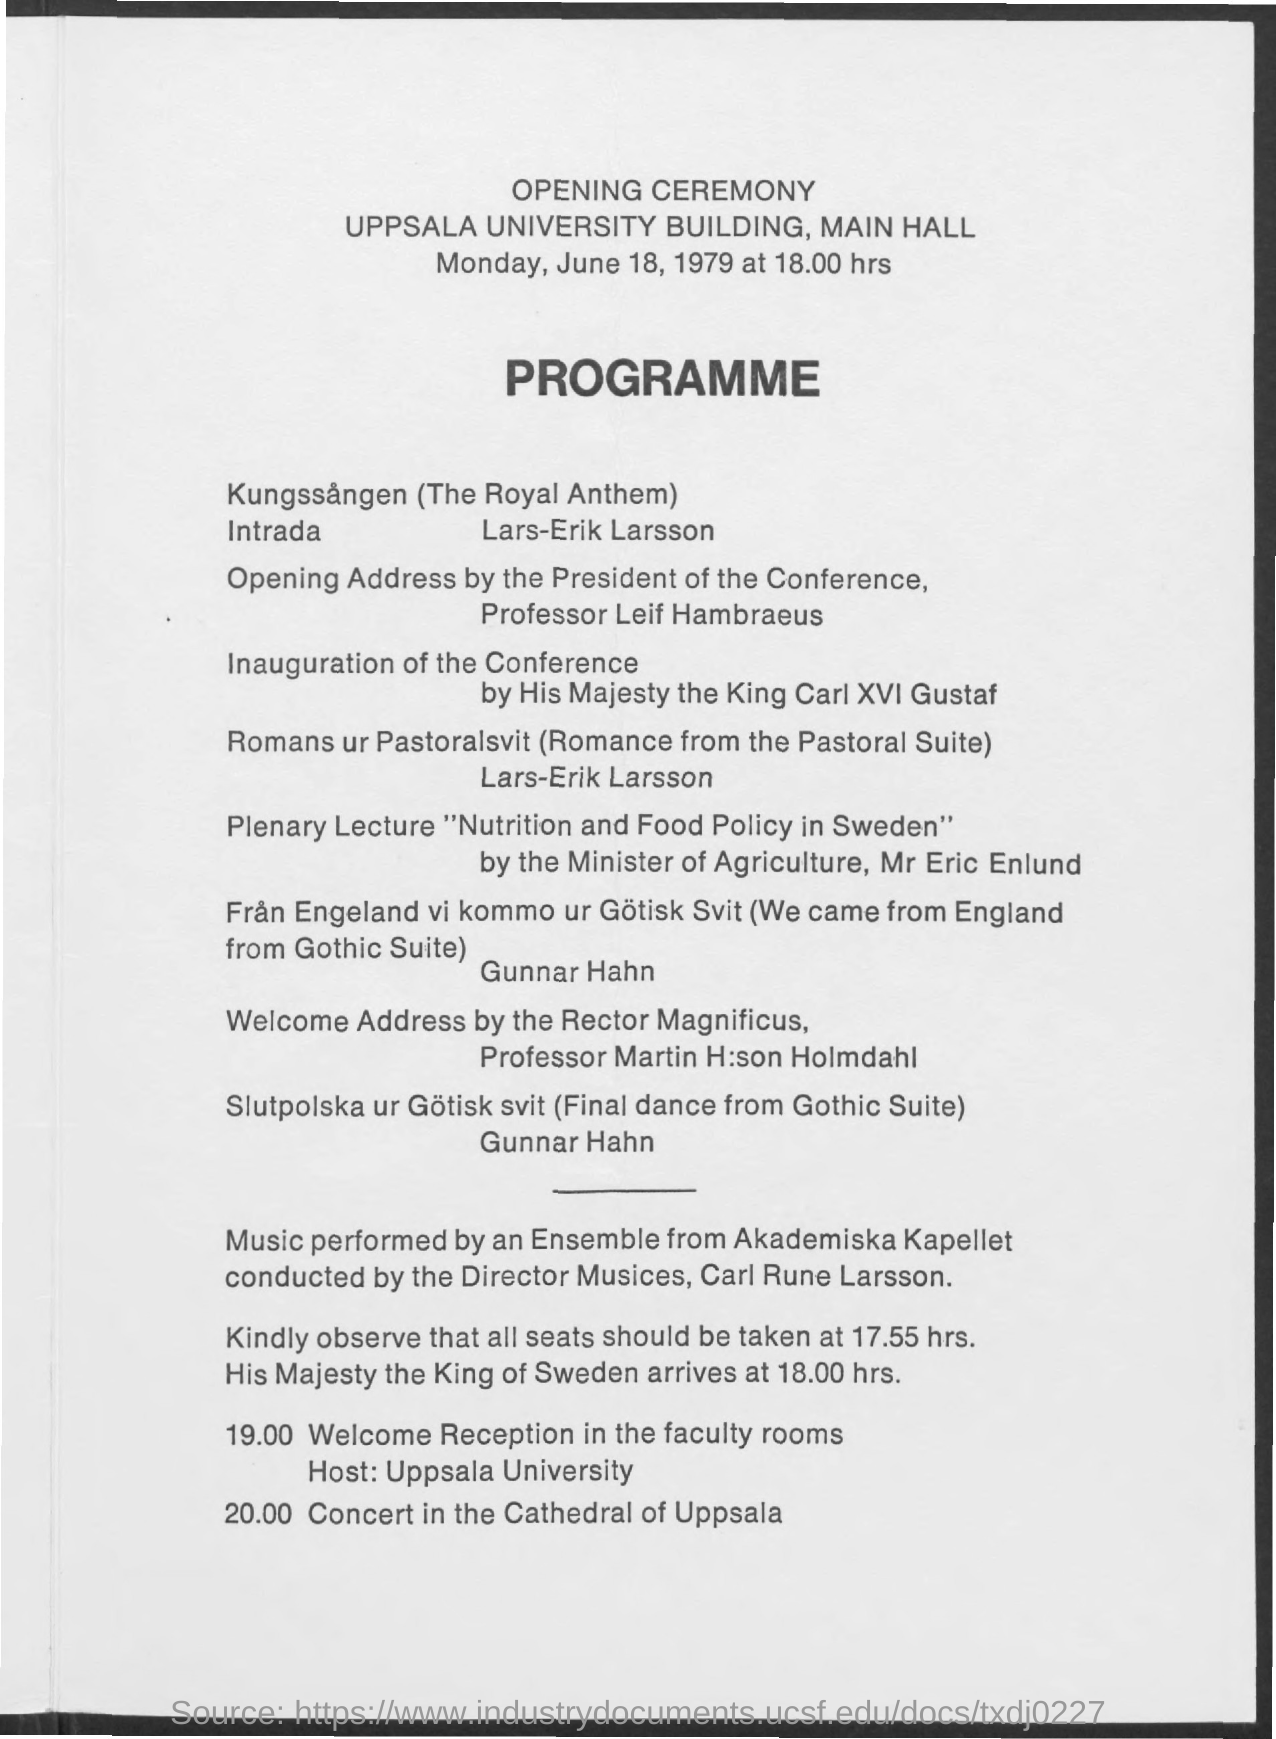What is the title of ceremony?
Give a very brief answer. Opening Ceremony. Where is the ceremony held at?
Keep it short and to the point. Uppsala university building, Main Hall. What day of the week is ceremony held on?
Keep it short and to the point. Monday. When is the ceremony held on?
Give a very brief answer. June 18, 1979. At what time would ceremony start at?
Provide a succinct answer. 18.00 hrs. Who is the host for welcome reception in the faculty rooms?
Give a very brief answer. Uppsala University. What time is scheduled for concert in the cathedral of uppsala?
Keep it short and to the point. 20.00. Who is the president of the conference?
Your response must be concise. Professor Leif Hambraeus. 